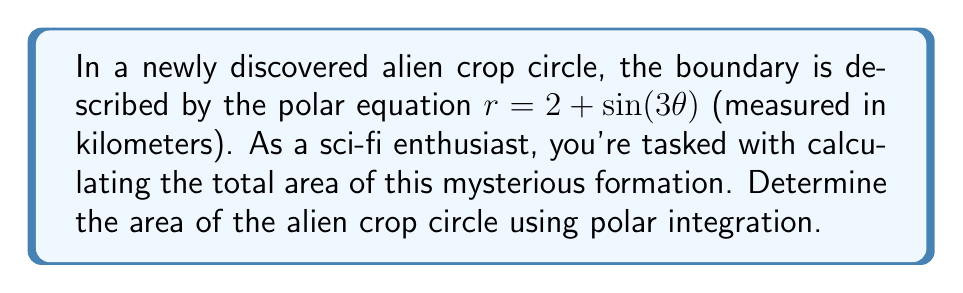Can you answer this question? To find the area of the region enclosed by the polar curve $r = 2 + \sin(3\theta)$, we'll use the formula for area in polar coordinates:

$$A = \frac{1}{2} \int_{0}^{2\pi} r^2 d\theta$$

Let's break this down step-by-step:

1) First, we square the given equation:
   $r^2 = (2 + \sin(3\theta))^2 = 4 + 4\sin(3\theta) + \sin^2(3\theta)$

2) Now, we integrate this from 0 to $2\pi$:
   $$A = \frac{1}{2} \int_{0}^{2\pi} (4 + 4\sin(3\theta) + \sin^2(3\theta)) d\theta$$

3) Let's integrate each term separately:
   - $\int_{0}^{2\pi} 4 d\theta = 4\theta \big|_{0}^{2\pi} = 8\pi$
   - $\int_{0}^{2\pi} 4\sin(3\theta) d\theta = -\frac{4}{3}\cos(3\theta) \big|_{0}^{2\pi} = 0$
   - For $\int_{0}^{2\pi} \sin^2(3\theta) d\theta$, we can use the identity $\sin^2 x = \frac{1}{2}(1 - \cos(2x))$:
     $\int_{0}^{2\pi} \sin^2(3\theta) d\theta = \int_{0}^{2\pi} \frac{1}{2}(1 - \cos(6\theta)) d\theta = \frac{1}{2}\theta - \frac{1}{12}\sin(6\theta) \big|_{0}^{2\pi} = \pi$

4) Adding these results:
   $$A = \frac{1}{2}(8\pi + 0 + \pi) = \frac{9\pi}{2}$$

Therefore, the area of the alien crop circle is $\frac{9\pi}{2}$ square kilometers.
Answer: $\frac{9\pi}{2}$ square kilometers 